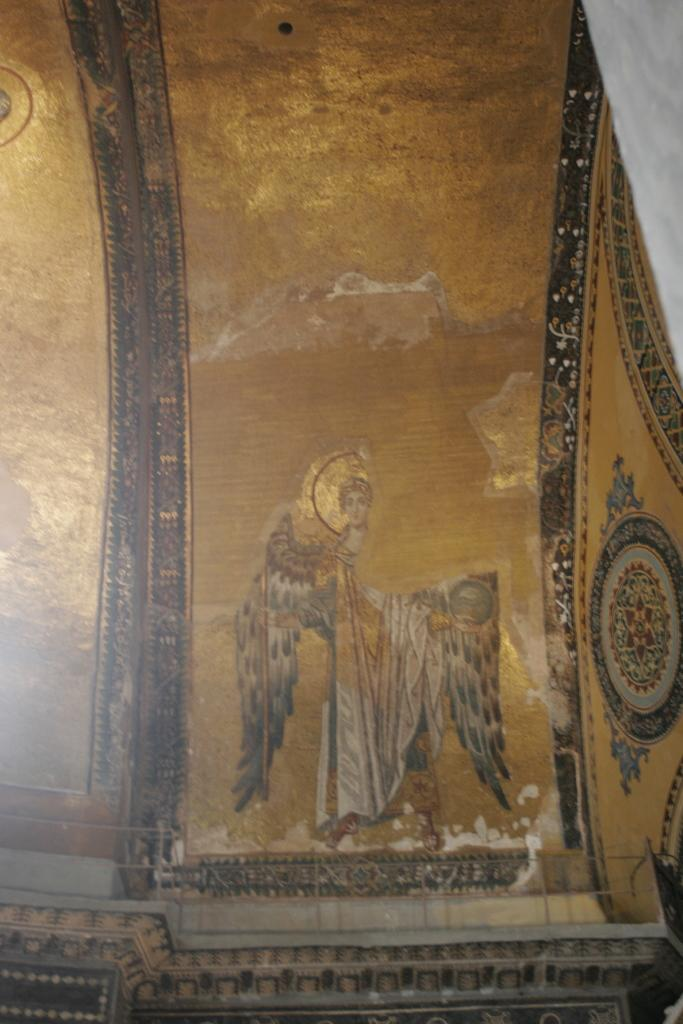What can be seen on the wall in the image? There is a wall with a design in the image. Can you describe the object on the right side of the image? There is a white-colored object on the right side of the image. What type of glue is being used to attach the floor to the wall in the image? There is no glue or floor present in the image; it only features a wall with a design and a white-colored object on the right side. 